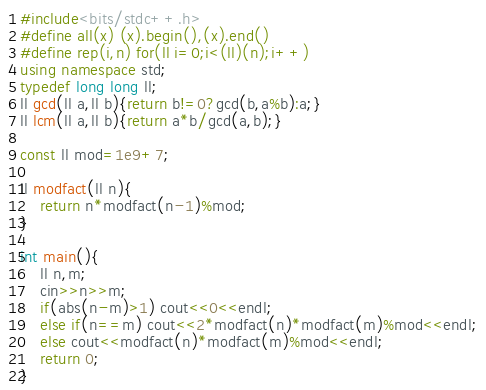<code> <loc_0><loc_0><loc_500><loc_500><_C++_>#include<bits/stdc++.h>
#define all(x) (x).begin(),(x).end()
#define rep(i,n) for(ll i=0;i<(ll)(n);i++)
using namespace std;
typedef long long ll;
ll gcd(ll a,ll b){return b!=0?gcd(b,a%b):a;}
ll lcm(ll a,ll b){return a*b/gcd(a,b);}

const ll mod=1e9+7;

ll modfact(ll n){
    return n*modfact(n-1)%mod;
}

int main(){
    ll n,m;
    cin>>n>>m;
    if(abs(n-m)>1) cout<<0<<endl;
    else if(n==m) cout<<2*modfact(n)*modfact(m)%mod<<endl;
    else cout<<modfact(n)*modfact(m)%mod<<endl;
    return 0;
}</code> 